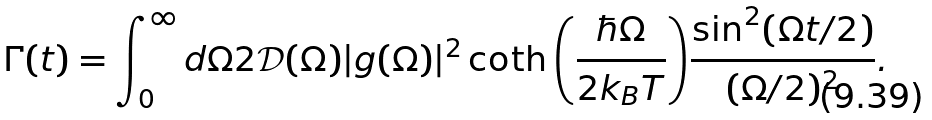<formula> <loc_0><loc_0><loc_500><loc_500>\Gamma ( t ) = \int _ { 0 } ^ { \infty } d \Omega 2 \mathcal { D } ( \Omega ) | g ( \Omega ) | ^ { 2 } \coth { \left ( \frac { \hbar { \Omega } } { 2 k _ { B } T } \right ) } \frac { \sin ^ { 2 } ( \Omega t / 2 ) } { ( \Omega / 2 ) ^ { 2 } } .</formula> 